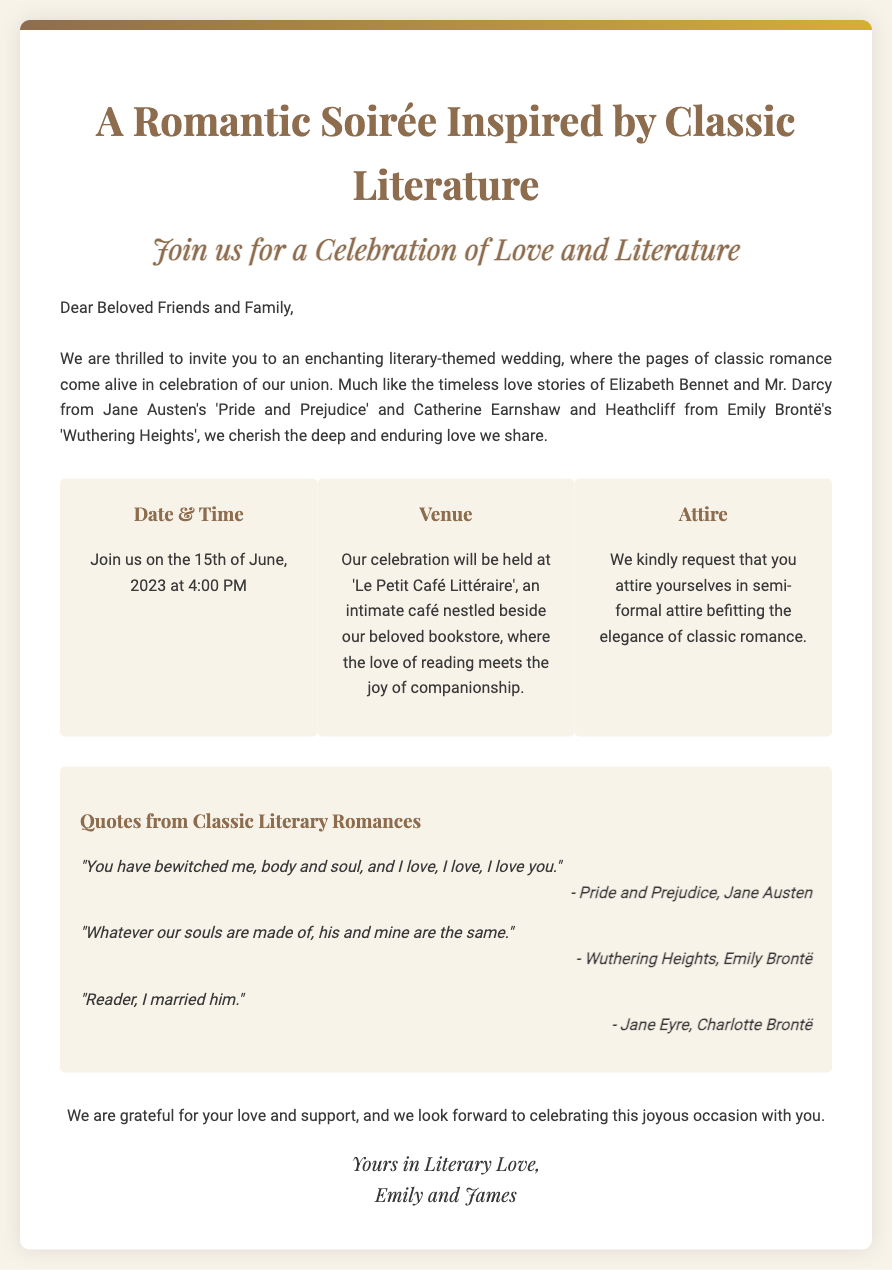What is the date of the wedding? The wedding is scheduled to take place on the 15th of June, 2023, as mentioned in the details section of the invitation.
Answer: 15th of June, 2023 What time does the wedding start? The invitation states that the celebration will begin at 4:00 PM.
Answer: 4:00 PM What is the name of the café where the event will be held? The venue for the celebration is 'Le Petit Café Littéraire', noted in the details section of the document.
Answer: Le Petit Café Littéraire Which classic novel features Elizabeth Bennet and Mr. Darcy? The document references 'Pride and Prejudice' by Jane Austen, which includes these characters in its narrative.
Answer: Pride and Prejudice What attire is requested for the guests? The invitation suggests semi-formal attire to align with the elegance of the theme.
Answer: Semi-formal attire What theme is the wedding based on? The wedding invitation emphasizes a literary theme inspired by classic romance, showcasing the couple's love for literature.
Answer: Literary theme What quote is attributed to Jane Eyre? The document contains the quote "Reader, I married him." attributed to Jane Eyre, a work by Charlotte Brontë.
Answer: Reader, I married him Who are the hosts of the wedding? The closing section of the invitation indicates that Emily and James are the hosts of the event.
Answer: Emily and James 